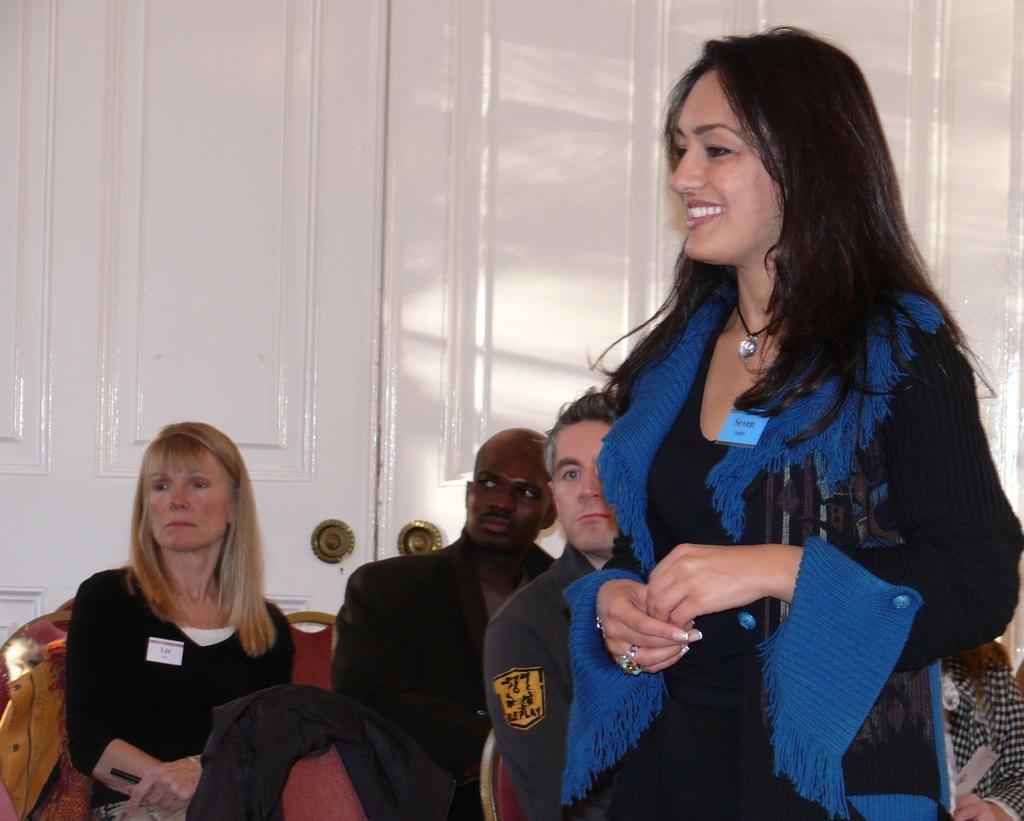In one or two sentences, can you explain what this image depicts? In this picture I can see there are few people sitting and here there is a woman standing and smiling. In the backdrop there is a white color door. 